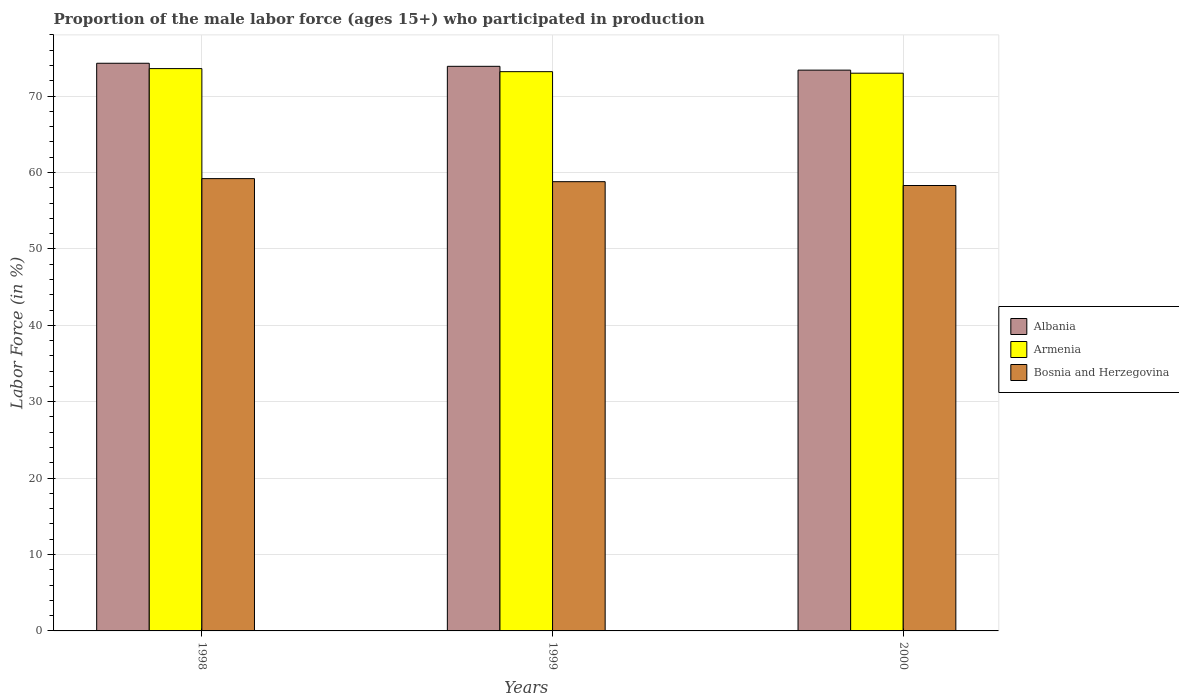How many different coloured bars are there?
Keep it short and to the point. 3. Are the number of bars on each tick of the X-axis equal?
Make the answer very short. Yes. How many bars are there on the 3rd tick from the left?
Give a very brief answer. 3. In how many cases, is the number of bars for a given year not equal to the number of legend labels?
Offer a very short reply. 0. What is the proportion of the male labor force who participated in production in Albania in 1998?
Your answer should be compact. 74.3. Across all years, what is the maximum proportion of the male labor force who participated in production in Armenia?
Make the answer very short. 73.6. Across all years, what is the minimum proportion of the male labor force who participated in production in Armenia?
Keep it short and to the point. 73. What is the total proportion of the male labor force who participated in production in Bosnia and Herzegovina in the graph?
Provide a succinct answer. 176.3. What is the difference between the proportion of the male labor force who participated in production in Albania in 1998 and that in 1999?
Offer a terse response. 0.4. What is the difference between the proportion of the male labor force who participated in production in Bosnia and Herzegovina in 2000 and the proportion of the male labor force who participated in production in Armenia in 1999?
Provide a short and direct response. -14.9. What is the average proportion of the male labor force who participated in production in Bosnia and Herzegovina per year?
Give a very brief answer. 58.77. In the year 1998, what is the difference between the proportion of the male labor force who participated in production in Albania and proportion of the male labor force who participated in production in Armenia?
Your answer should be compact. 0.7. What is the ratio of the proportion of the male labor force who participated in production in Bosnia and Herzegovina in 1999 to that in 2000?
Ensure brevity in your answer.  1.01. Is the proportion of the male labor force who participated in production in Armenia in 1999 less than that in 2000?
Your answer should be compact. No. What is the difference between the highest and the second highest proportion of the male labor force who participated in production in Armenia?
Your answer should be compact. 0.4. What is the difference between the highest and the lowest proportion of the male labor force who participated in production in Bosnia and Herzegovina?
Your response must be concise. 0.9. In how many years, is the proportion of the male labor force who participated in production in Bosnia and Herzegovina greater than the average proportion of the male labor force who participated in production in Bosnia and Herzegovina taken over all years?
Give a very brief answer. 2. What does the 3rd bar from the left in 1999 represents?
Your response must be concise. Bosnia and Herzegovina. What does the 2nd bar from the right in 1998 represents?
Provide a short and direct response. Armenia. Is it the case that in every year, the sum of the proportion of the male labor force who participated in production in Albania and proportion of the male labor force who participated in production in Armenia is greater than the proportion of the male labor force who participated in production in Bosnia and Herzegovina?
Make the answer very short. Yes. What is the difference between two consecutive major ticks on the Y-axis?
Your answer should be compact. 10. Are the values on the major ticks of Y-axis written in scientific E-notation?
Provide a short and direct response. No. How many legend labels are there?
Provide a short and direct response. 3. What is the title of the graph?
Offer a very short reply. Proportion of the male labor force (ages 15+) who participated in production. What is the Labor Force (in %) of Albania in 1998?
Offer a very short reply. 74.3. What is the Labor Force (in %) in Armenia in 1998?
Your answer should be very brief. 73.6. What is the Labor Force (in %) in Bosnia and Herzegovina in 1998?
Offer a very short reply. 59.2. What is the Labor Force (in %) in Albania in 1999?
Give a very brief answer. 73.9. What is the Labor Force (in %) of Armenia in 1999?
Your response must be concise. 73.2. What is the Labor Force (in %) in Bosnia and Herzegovina in 1999?
Offer a terse response. 58.8. What is the Labor Force (in %) of Albania in 2000?
Your answer should be very brief. 73.4. What is the Labor Force (in %) of Bosnia and Herzegovina in 2000?
Keep it short and to the point. 58.3. Across all years, what is the maximum Labor Force (in %) in Albania?
Keep it short and to the point. 74.3. Across all years, what is the maximum Labor Force (in %) of Armenia?
Your answer should be very brief. 73.6. Across all years, what is the maximum Labor Force (in %) of Bosnia and Herzegovina?
Offer a terse response. 59.2. Across all years, what is the minimum Labor Force (in %) in Albania?
Keep it short and to the point. 73.4. Across all years, what is the minimum Labor Force (in %) of Armenia?
Offer a very short reply. 73. Across all years, what is the minimum Labor Force (in %) of Bosnia and Herzegovina?
Your answer should be very brief. 58.3. What is the total Labor Force (in %) in Albania in the graph?
Your response must be concise. 221.6. What is the total Labor Force (in %) of Armenia in the graph?
Provide a short and direct response. 219.8. What is the total Labor Force (in %) of Bosnia and Herzegovina in the graph?
Your answer should be very brief. 176.3. What is the difference between the Labor Force (in %) in Albania in 1998 and that in 2000?
Your answer should be compact. 0.9. What is the difference between the Labor Force (in %) of Armenia in 1998 and that in 2000?
Provide a short and direct response. 0.6. What is the difference between the Labor Force (in %) in Bosnia and Herzegovina in 1998 and that in 2000?
Offer a very short reply. 0.9. What is the difference between the Labor Force (in %) of Albania in 1999 and that in 2000?
Provide a succinct answer. 0.5. What is the difference between the Labor Force (in %) in Albania in 1998 and the Labor Force (in %) in Armenia in 1999?
Provide a succinct answer. 1.1. What is the difference between the Labor Force (in %) of Armenia in 1998 and the Labor Force (in %) of Bosnia and Herzegovina in 1999?
Ensure brevity in your answer.  14.8. What is the difference between the Labor Force (in %) in Albania in 1998 and the Labor Force (in %) in Armenia in 2000?
Provide a succinct answer. 1.3. What is the difference between the Labor Force (in %) in Armenia in 1998 and the Labor Force (in %) in Bosnia and Herzegovina in 2000?
Your response must be concise. 15.3. What is the difference between the Labor Force (in %) in Albania in 1999 and the Labor Force (in %) in Armenia in 2000?
Ensure brevity in your answer.  0.9. What is the difference between the Labor Force (in %) of Armenia in 1999 and the Labor Force (in %) of Bosnia and Herzegovina in 2000?
Keep it short and to the point. 14.9. What is the average Labor Force (in %) of Albania per year?
Give a very brief answer. 73.87. What is the average Labor Force (in %) in Armenia per year?
Your answer should be very brief. 73.27. What is the average Labor Force (in %) of Bosnia and Herzegovina per year?
Your response must be concise. 58.77. In the year 1998, what is the difference between the Labor Force (in %) of Albania and Labor Force (in %) of Armenia?
Your answer should be compact. 0.7. In the year 1998, what is the difference between the Labor Force (in %) of Albania and Labor Force (in %) of Bosnia and Herzegovina?
Give a very brief answer. 15.1. In the year 1999, what is the difference between the Labor Force (in %) in Albania and Labor Force (in %) in Armenia?
Keep it short and to the point. 0.7. In the year 2000, what is the difference between the Labor Force (in %) of Armenia and Labor Force (in %) of Bosnia and Herzegovina?
Offer a terse response. 14.7. What is the ratio of the Labor Force (in %) in Albania in 1998 to that in 1999?
Make the answer very short. 1.01. What is the ratio of the Labor Force (in %) in Bosnia and Herzegovina in 1998 to that in 1999?
Ensure brevity in your answer.  1.01. What is the ratio of the Labor Force (in %) in Albania in 1998 to that in 2000?
Your response must be concise. 1.01. What is the ratio of the Labor Force (in %) of Armenia in 1998 to that in 2000?
Make the answer very short. 1.01. What is the ratio of the Labor Force (in %) of Bosnia and Herzegovina in 1998 to that in 2000?
Offer a very short reply. 1.02. What is the ratio of the Labor Force (in %) of Albania in 1999 to that in 2000?
Your answer should be very brief. 1.01. What is the ratio of the Labor Force (in %) in Bosnia and Herzegovina in 1999 to that in 2000?
Your answer should be compact. 1.01. What is the difference between the highest and the second highest Labor Force (in %) in Albania?
Give a very brief answer. 0.4. What is the difference between the highest and the lowest Labor Force (in %) of Armenia?
Your answer should be compact. 0.6. 